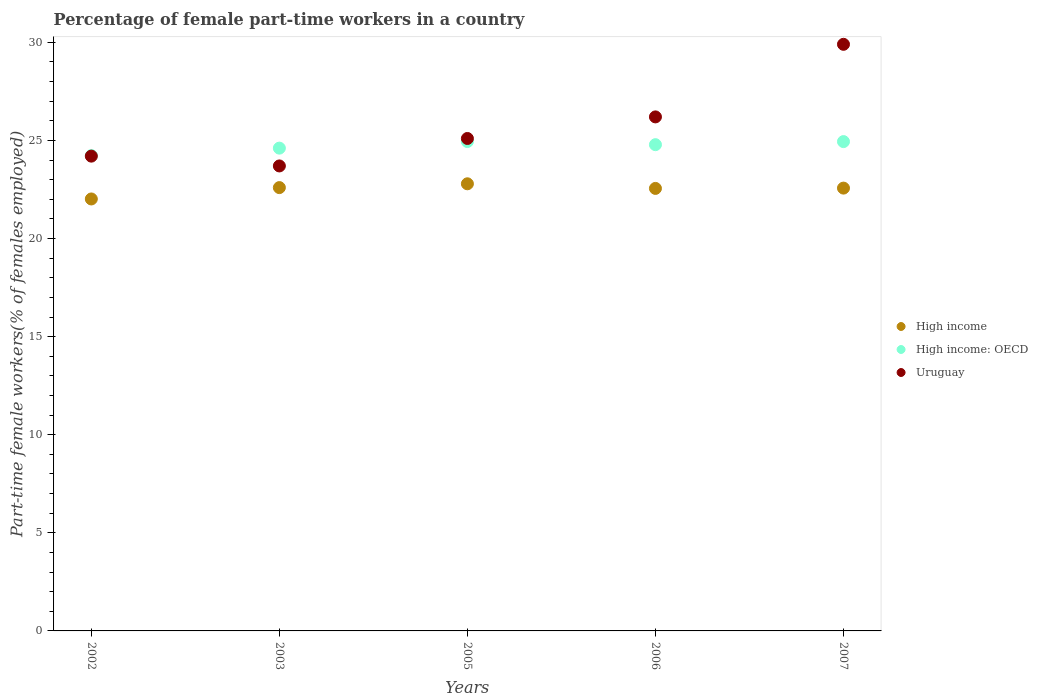Is the number of dotlines equal to the number of legend labels?
Provide a succinct answer. Yes. What is the percentage of female part-time workers in High income in 2007?
Your answer should be compact. 22.57. Across all years, what is the maximum percentage of female part-time workers in High income?
Your answer should be compact. 22.79. Across all years, what is the minimum percentage of female part-time workers in High income?
Your answer should be very brief. 22.02. What is the total percentage of female part-time workers in High income in the graph?
Offer a terse response. 112.53. What is the difference between the percentage of female part-time workers in High income in 2003 and that in 2007?
Your answer should be very brief. 0.03. What is the difference between the percentage of female part-time workers in High income: OECD in 2005 and the percentage of female part-time workers in High income in 2007?
Ensure brevity in your answer.  2.37. What is the average percentage of female part-time workers in High income: OECD per year?
Your response must be concise. 24.7. In the year 2003, what is the difference between the percentage of female part-time workers in High income: OECD and percentage of female part-time workers in High income?
Ensure brevity in your answer.  2.01. What is the ratio of the percentage of female part-time workers in Uruguay in 2003 to that in 2005?
Provide a succinct answer. 0.94. Is the percentage of female part-time workers in High income: OECD in 2005 less than that in 2006?
Offer a very short reply. No. What is the difference between the highest and the second highest percentage of female part-time workers in High income: OECD?
Your answer should be very brief. 0. What is the difference between the highest and the lowest percentage of female part-time workers in High income: OECD?
Make the answer very short. 0.72. Is the percentage of female part-time workers in Uruguay strictly greater than the percentage of female part-time workers in High income over the years?
Make the answer very short. Yes. How many dotlines are there?
Your response must be concise. 3. How many years are there in the graph?
Provide a succinct answer. 5. What is the difference between two consecutive major ticks on the Y-axis?
Provide a short and direct response. 5. Are the values on the major ticks of Y-axis written in scientific E-notation?
Ensure brevity in your answer.  No. Does the graph contain any zero values?
Offer a terse response. No. Where does the legend appear in the graph?
Your answer should be very brief. Center right. What is the title of the graph?
Make the answer very short. Percentage of female part-time workers in a country. Does "Antigua and Barbuda" appear as one of the legend labels in the graph?
Your answer should be very brief. No. What is the label or title of the X-axis?
Ensure brevity in your answer.  Years. What is the label or title of the Y-axis?
Give a very brief answer. Part-time female workers(% of females employed). What is the Part-time female workers(% of females employed) in High income in 2002?
Give a very brief answer. 22.02. What is the Part-time female workers(% of females employed) of High income: OECD in 2002?
Offer a very short reply. 24.23. What is the Part-time female workers(% of females employed) of Uruguay in 2002?
Your answer should be very brief. 24.2. What is the Part-time female workers(% of females employed) of High income in 2003?
Offer a terse response. 22.6. What is the Part-time female workers(% of females employed) of High income: OECD in 2003?
Your answer should be compact. 24.61. What is the Part-time female workers(% of females employed) of Uruguay in 2003?
Your answer should be very brief. 23.7. What is the Part-time female workers(% of females employed) in High income in 2005?
Offer a very short reply. 22.79. What is the Part-time female workers(% of females employed) of High income: OECD in 2005?
Your answer should be compact. 24.94. What is the Part-time female workers(% of females employed) of Uruguay in 2005?
Your response must be concise. 25.1. What is the Part-time female workers(% of females employed) in High income in 2006?
Offer a very short reply. 22.55. What is the Part-time female workers(% of females employed) of High income: OECD in 2006?
Give a very brief answer. 24.78. What is the Part-time female workers(% of females employed) in Uruguay in 2006?
Keep it short and to the point. 26.2. What is the Part-time female workers(% of females employed) of High income in 2007?
Ensure brevity in your answer.  22.57. What is the Part-time female workers(% of females employed) of High income: OECD in 2007?
Give a very brief answer. 24.94. What is the Part-time female workers(% of females employed) in Uruguay in 2007?
Offer a very short reply. 29.9. Across all years, what is the maximum Part-time female workers(% of females employed) of High income?
Offer a terse response. 22.79. Across all years, what is the maximum Part-time female workers(% of females employed) of High income: OECD?
Offer a very short reply. 24.94. Across all years, what is the maximum Part-time female workers(% of females employed) of Uruguay?
Offer a terse response. 29.9. Across all years, what is the minimum Part-time female workers(% of females employed) of High income?
Your answer should be very brief. 22.02. Across all years, what is the minimum Part-time female workers(% of females employed) in High income: OECD?
Ensure brevity in your answer.  24.23. Across all years, what is the minimum Part-time female workers(% of females employed) of Uruguay?
Make the answer very short. 23.7. What is the total Part-time female workers(% of females employed) in High income in the graph?
Offer a very short reply. 112.53. What is the total Part-time female workers(% of females employed) of High income: OECD in the graph?
Offer a terse response. 123.51. What is the total Part-time female workers(% of females employed) of Uruguay in the graph?
Offer a very short reply. 129.1. What is the difference between the Part-time female workers(% of females employed) of High income in 2002 and that in 2003?
Ensure brevity in your answer.  -0.58. What is the difference between the Part-time female workers(% of females employed) in High income: OECD in 2002 and that in 2003?
Make the answer very short. -0.38. What is the difference between the Part-time female workers(% of females employed) of Uruguay in 2002 and that in 2003?
Ensure brevity in your answer.  0.5. What is the difference between the Part-time female workers(% of females employed) of High income in 2002 and that in 2005?
Make the answer very short. -0.77. What is the difference between the Part-time female workers(% of females employed) in High income: OECD in 2002 and that in 2005?
Provide a short and direct response. -0.72. What is the difference between the Part-time female workers(% of females employed) of High income in 2002 and that in 2006?
Ensure brevity in your answer.  -0.54. What is the difference between the Part-time female workers(% of females employed) in High income: OECD in 2002 and that in 2006?
Make the answer very short. -0.56. What is the difference between the Part-time female workers(% of females employed) in Uruguay in 2002 and that in 2006?
Provide a succinct answer. -2. What is the difference between the Part-time female workers(% of females employed) of High income in 2002 and that in 2007?
Your response must be concise. -0.55. What is the difference between the Part-time female workers(% of females employed) in High income: OECD in 2002 and that in 2007?
Provide a short and direct response. -0.71. What is the difference between the Part-time female workers(% of females employed) in High income in 2003 and that in 2005?
Offer a terse response. -0.19. What is the difference between the Part-time female workers(% of females employed) of High income: OECD in 2003 and that in 2005?
Provide a succinct answer. -0.34. What is the difference between the Part-time female workers(% of females employed) in Uruguay in 2003 and that in 2005?
Your response must be concise. -1.4. What is the difference between the Part-time female workers(% of females employed) of High income in 2003 and that in 2006?
Your answer should be compact. 0.04. What is the difference between the Part-time female workers(% of females employed) in High income: OECD in 2003 and that in 2006?
Ensure brevity in your answer.  -0.18. What is the difference between the Part-time female workers(% of females employed) in Uruguay in 2003 and that in 2006?
Keep it short and to the point. -2.5. What is the difference between the Part-time female workers(% of females employed) of High income in 2003 and that in 2007?
Give a very brief answer. 0.03. What is the difference between the Part-time female workers(% of females employed) in High income: OECD in 2003 and that in 2007?
Offer a terse response. -0.33. What is the difference between the Part-time female workers(% of females employed) in High income in 2005 and that in 2006?
Provide a short and direct response. 0.24. What is the difference between the Part-time female workers(% of females employed) of High income: OECD in 2005 and that in 2006?
Your answer should be compact. 0.16. What is the difference between the Part-time female workers(% of females employed) in High income in 2005 and that in 2007?
Make the answer very short. 0.22. What is the difference between the Part-time female workers(% of females employed) in High income: OECD in 2005 and that in 2007?
Make the answer very short. 0. What is the difference between the Part-time female workers(% of females employed) in High income in 2006 and that in 2007?
Provide a short and direct response. -0.02. What is the difference between the Part-time female workers(% of females employed) in High income: OECD in 2006 and that in 2007?
Give a very brief answer. -0.16. What is the difference between the Part-time female workers(% of females employed) in High income in 2002 and the Part-time female workers(% of females employed) in High income: OECD in 2003?
Your response must be concise. -2.59. What is the difference between the Part-time female workers(% of females employed) of High income in 2002 and the Part-time female workers(% of females employed) of Uruguay in 2003?
Your answer should be compact. -1.68. What is the difference between the Part-time female workers(% of females employed) of High income: OECD in 2002 and the Part-time female workers(% of females employed) of Uruguay in 2003?
Provide a short and direct response. 0.53. What is the difference between the Part-time female workers(% of females employed) in High income in 2002 and the Part-time female workers(% of females employed) in High income: OECD in 2005?
Give a very brief answer. -2.93. What is the difference between the Part-time female workers(% of females employed) in High income in 2002 and the Part-time female workers(% of females employed) in Uruguay in 2005?
Your answer should be compact. -3.08. What is the difference between the Part-time female workers(% of females employed) of High income: OECD in 2002 and the Part-time female workers(% of females employed) of Uruguay in 2005?
Offer a terse response. -0.87. What is the difference between the Part-time female workers(% of females employed) of High income in 2002 and the Part-time female workers(% of females employed) of High income: OECD in 2006?
Ensure brevity in your answer.  -2.77. What is the difference between the Part-time female workers(% of females employed) of High income in 2002 and the Part-time female workers(% of females employed) of Uruguay in 2006?
Give a very brief answer. -4.18. What is the difference between the Part-time female workers(% of females employed) of High income: OECD in 2002 and the Part-time female workers(% of females employed) of Uruguay in 2006?
Make the answer very short. -1.97. What is the difference between the Part-time female workers(% of females employed) of High income in 2002 and the Part-time female workers(% of females employed) of High income: OECD in 2007?
Your response must be concise. -2.92. What is the difference between the Part-time female workers(% of females employed) of High income in 2002 and the Part-time female workers(% of females employed) of Uruguay in 2007?
Your answer should be compact. -7.88. What is the difference between the Part-time female workers(% of females employed) of High income: OECD in 2002 and the Part-time female workers(% of females employed) of Uruguay in 2007?
Keep it short and to the point. -5.67. What is the difference between the Part-time female workers(% of females employed) of High income in 2003 and the Part-time female workers(% of females employed) of High income: OECD in 2005?
Offer a very short reply. -2.35. What is the difference between the Part-time female workers(% of females employed) of High income in 2003 and the Part-time female workers(% of females employed) of Uruguay in 2005?
Ensure brevity in your answer.  -2.5. What is the difference between the Part-time female workers(% of females employed) of High income: OECD in 2003 and the Part-time female workers(% of females employed) of Uruguay in 2005?
Make the answer very short. -0.49. What is the difference between the Part-time female workers(% of females employed) in High income in 2003 and the Part-time female workers(% of females employed) in High income: OECD in 2006?
Make the answer very short. -2.19. What is the difference between the Part-time female workers(% of females employed) of High income in 2003 and the Part-time female workers(% of females employed) of Uruguay in 2006?
Offer a terse response. -3.6. What is the difference between the Part-time female workers(% of females employed) in High income: OECD in 2003 and the Part-time female workers(% of females employed) in Uruguay in 2006?
Ensure brevity in your answer.  -1.59. What is the difference between the Part-time female workers(% of females employed) in High income in 2003 and the Part-time female workers(% of females employed) in High income: OECD in 2007?
Offer a terse response. -2.34. What is the difference between the Part-time female workers(% of females employed) in High income in 2003 and the Part-time female workers(% of females employed) in Uruguay in 2007?
Your answer should be very brief. -7.3. What is the difference between the Part-time female workers(% of females employed) in High income: OECD in 2003 and the Part-time female workers(% of females employed) in Uruguay in 2007?
Your response must be concise. -5.29. What is the difference between the Part-time female workers(% of females employed) in High income in 2005 and the Part-time female workers(% of females employed) in High income: OECD in 2006?
Offer a terse response. -1.99. What is the difference between the Part-time female workers(% of females employed) of High income in 2005 and the Part-time female workers(% of females employed) of Uruguay in 2006?
Ensure brevity in your answer.  -3.41. What is the difference between the Part-time female workers(% of females employed) in High income: OECD in 2005 and the Part-time female workers(% of females employed) in Uruguay in 2006?
Provide a short and direct response. -1.26. What is the difference between the Part-time female workers(% of females employed) of High income in 2005 and the Part-time female workers(% of females employed) of High income: OECD in 2007?
Keep it short and to the point. -2.15. What is the difference between the Part-time female workers(% of females employed) of High income in 2005 and the Part-time female workers(% of females employed) of Uruguay in 2007?
Offer a terse response. -7.11. What is the difference between the Part-time female workers(% of females employed) of High income: OECD in 2005 and the Part-time female workers(% of females employed) of Uruguay in 2007?
Provide a succinct answer. -4.96. What is the difference between the Part-time female workers(% of females employed) in High income in 2006 and the Part-time female workers(% of females employed) in High income: OECD in 2007?
Keep it short and to the point. -2.39. What is the difference between the Part-time female workers(% of females employed) in High income in 2006 and the Part-time female workers(% of females employed) in Uruguay in 2007?
Your answer should be compact. -7.35. What is the difference between the Part-time female workers(% of females employed) in High income: OECD in 2006 and the Part-time female workers(% of females employed) in Uruguay in 2007?
Offer a terse response. -5.12. What is the average Part-time female workers(% of females employed) of High income per year?
Offer a very short reply. 22.51. What is the average Part-time female workers(% of females employed) of High income: OECD per year?
Your answer should be very brief. 24.7. What is the average Part-time female workers(% of females employed) in Uruguay per year?
Keep it short and to the point. 25.82. In the year 2002, what is the difference between the Part-time female workers(% of females employed) in High income and Part-time female workers(% of females employed) in High income: OECD?
Provide a succinct answer. -2.21. In the year 2002, what is the difference between the Part-time female workers(% of females employed) of High income and Part-time female workers(% of females employed) of Uruguay?
Offer a very short reply. -2.18. In the year 2002, what is the difference between the Part-time female workers(% of females employed) in High income: OECD and Part-time female workers(% of females employed) in Uruguay?
Your response must be concise. 0.03. In the year 2003, what is the difference between the Part-time female workers(% of females employed) of High income and Part-time female workers(% of females employed) of High income: OECD?
Keep it short and to the point. -2.01. In the year 2003, what is the difference between the Part-time female workers(% of females employed) of High income and Part-time female workers(% of females employed) of Uruguay?
Give a very brief answer. -1.1. In the year 2003, what is the difference between the Part-time female workers(% of females employed) in High income: OECD and Part-time female workers(% of females employed) in Uruguay?
Give a very brief answer. 0.91. In the year 2005, what is the difference between the Part-time female workers(% of females employed) of High income and Part-time female workers(% of females employed) of High income: OECD?
Make the answer very short. -2.15. In the year 2005, what is the difference between the Part-time female workers(% of females employed) of High income and Part-time female workers(% of females employed) of Uruguay?
Make the answer very short. -2.31. In the year 2005, what is the difference between the Part-time female workers(% of females employed) of High income: OECD and Part-time female workers(% of females employed) of Uruguay?
Make the answer very short. -0.16. In the year 2006, what is the difference between the Part-time female workers(% of females employed) in High income and Part-time female workers(% of females employed) in High income: OECD?
Give a very brief answer. -2.23. In the year 2006, what is the difference between the Part-time female workers(% of females employed) of High income and Part-time female workers(% of females employed) of Uruguay?
Make the answer very short. -3.65. In the year 2006, what is the difference between the Part-time female workers(% of females employed) in High income: OECD and Part-time female workers(% of females employed) in Uruguay?
Your answer should be compact. -1.42. In the year 2007, what is the difference between the Part-time female workers(% of females employed) in High income and Part-time female workers(% of females employed) in High income: OECD?
Your answer should be compact. -2.37. In the year 2007, what is the difference between the Part-time female workers(% of females employed) of High income and Part-time female workers(% of females employed) of Uruguay?
Give a very brief answer. -7.33. In the year 2007, what is the difference between the Part-time female workers(% of females employed) of High income: OECD and Part-time female workers(% of females employed) of Uruguay?
Give a very brief answer. -4.96. What is the ratio of the Part-time female workers(% of females employed) in High income in 2002 to that in 2003?
Give a very brief answer. 0.97. What is the ratio of the Part-time female workers(% of females employed) in High income: OECD in 2002 to that in 2003?
Provide a short and direct response. 0.98. What is the ratio of the Part-time female workers(% of females employed) of Uruguay in 2002 to that in 2003?
Provide a succinct answer. 1.02. What is the ratio of the Part-time female workers(% of females employed) of High income in 2002 to that in 2005?
Ensure brevity in your answer.  0.97. What is the ratio of the Part-time female workers(% of females employed) of High income: OECD in 2002 to that in 2005?
Your answer should be compact. 0.97. What is the ratio of the Part-time female workers(% of females employed) of Uruguay in 2002 to that in 2005?
Your answer should be very brief. 0.96. What is the ratio of the Part-time female workers(% of females employed) of High income in 2002 to that in 2006?
Offer a terse response. 0.98. What is the ratio of the Part-time female workers(% of females employed) of High income: OECD in 2002 to that in 2006?
Ensure brevity in your answer.  0.98. What is the ratio of the Part-time female workers(% of females employed) in Uruguay in 2002 to that in 2006?
Provide a succinct answer. 0.92. What is the ratio of the Part-time female workers(% of females employed) of High income in 2002 to that in 2007?
Keep it short and to the point. 0.98. What is the ratio of the Part-time female workers(% of females employed) in High income: OECD in 2002 to that in 2007?
Give a very brief answer. 0.97. What is the ratio of the Part-time female workers(% of females employed) in Uruguay in 2002 to that in 2007?
Your response must be concise. 0.81. What is the ratio of the Part-time female workers(% of females employed) of High income in 2003 to that in 2005?
Provide a succinct answer. 0.99. What is the ratio of the Part-time female workers(% of females employed) in High income: OECD in 2003 to that in 2005?
Offer a very short reply. 0.99. What is the ratio of the Part-time female workers(% of females employed) of Uruguay in 2003 to that in 2005?
Ensure brevity in your answer.  0.94. What is the ratio of the Part-time female workers(% of females employed) in High income in 2003 to that in 2006?
Ensure brevity in your answer.  1. What is the ratio of the Part-time female workers(% of females employed) in High income: OECD in 2003 to that in 2006?
Your answer should be very brief. 0.99. What is the ratio of the Part-time female workers(% of females employed) of Uruguay in 2003 to that in 2006?
Make the answer very short. 0.9. What is the ratio of the Part-time female workers(% of females employed) of High income in 2003 to that in 2007?
Your answer should be compact. 1. What is the ratio of the Part-time female workers(% of females employed) in High income: OECD in 2003 to that in 2007?
Make the answer very short. 0.99. What is the ratio of the Part-time female workers(% of females employed) in Uruguay in 2003 to that in 2007?
Keep it short and to the point. 0.79. What is the ratio of the Part-time female workers(% of females employed) in High income in 2005 to that in 2006?
Ensure brevity in your answer.  1.01. What is the ratio of the Part-time female workers(% of females employed) in High income: OECD in 2005 to that in 2006?
Offer a very short reply. 1.01. What is the ratio of the Part-time female workers(% of females employed) in Uruguay in 2005 to that in 2006?
Give a very brief answer. 0.96. What is the ratio of the Part-time female workers(% of females employed) of High income in 2005 to that in 2007?
Offer a terse response. 1.01. What is the ratio of the Part-time female workers(% of females employed) of High income: OECD in 2005 to that in 2007?
Give a very brief answer. 1. What is the ratio of the Part-time female workers(% of females employed) in Uruguay in 2005 to that in 2007?
Your answer should be compact. 0.84. What is the ratio of the Part-time female workers(% of females employed) in High income in 2006 to that in 2007?
Your answer should be very brief. 1. What is the ratio of the Part-time female workers(% of females employed) in Uruguay in 2006 to that in 2007?
Provide a short and direct response. 0.88. What is the difference between the highest and the second highest Part-time female workers(% of females employed) in High income?
Your answer should be compact. 0.19. What is the difference between the highest and the second highest Part-time female workers(% of females employed) of High income: OECD?
Offer a very short reply. 0. What is the difference between the highest and the lowest Part-time female workers(% of females employed) of High income?
Make the answer very short. 0.77. What is the difference between the highest and the lowest Part-time female workers(% of females employed) in High income: OECD?
Provide a short and direct response. 0.72. 